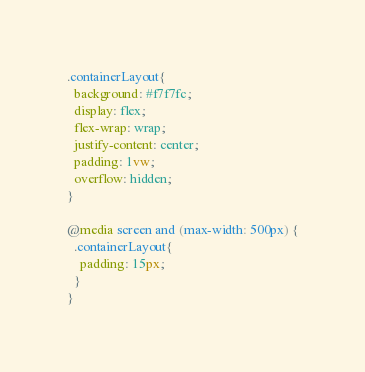Convert code to text. <code><loc_0><loc_0><loc_500><loc_500><_CSS_>.containerLayout{
  background: #f7f7fc;
  display: flex;
  flex-wrap: wrap;
  justify-content: center;
  padding: 1vw;
  overflow: hidden;
}

@media screen and (max-width: 500px) {
  .containerLayout{
    padding: 15px;
  }
}
</code> 